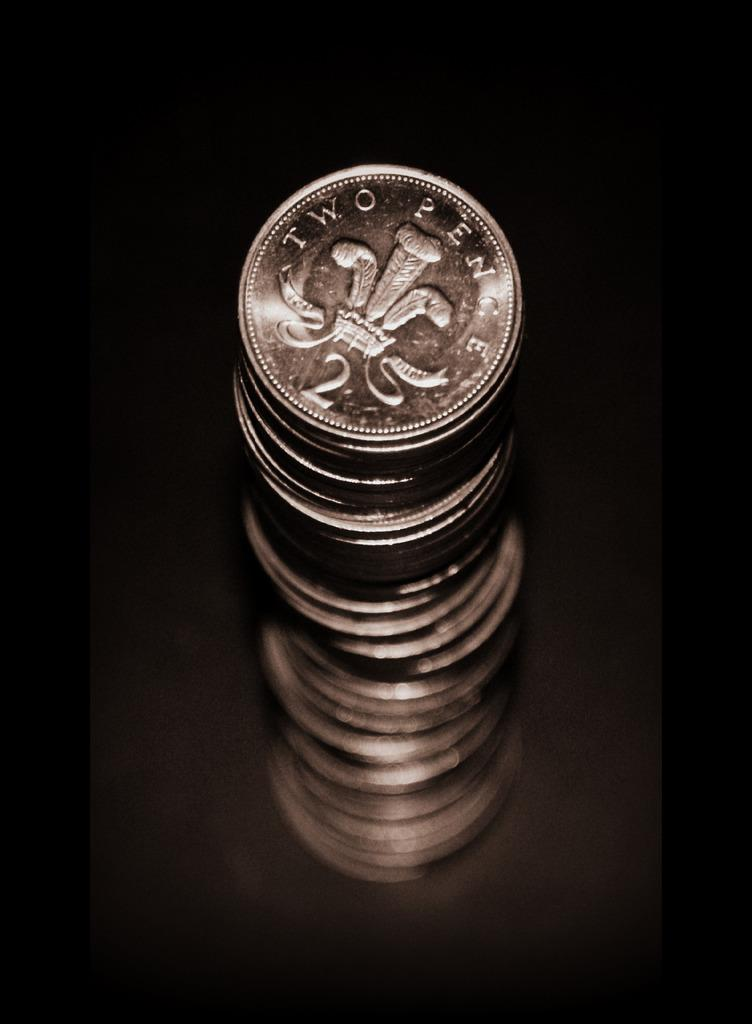<image>
Write a terse but informative summary of the picture. A stacked silver coins of two pence placed in a dark space. 